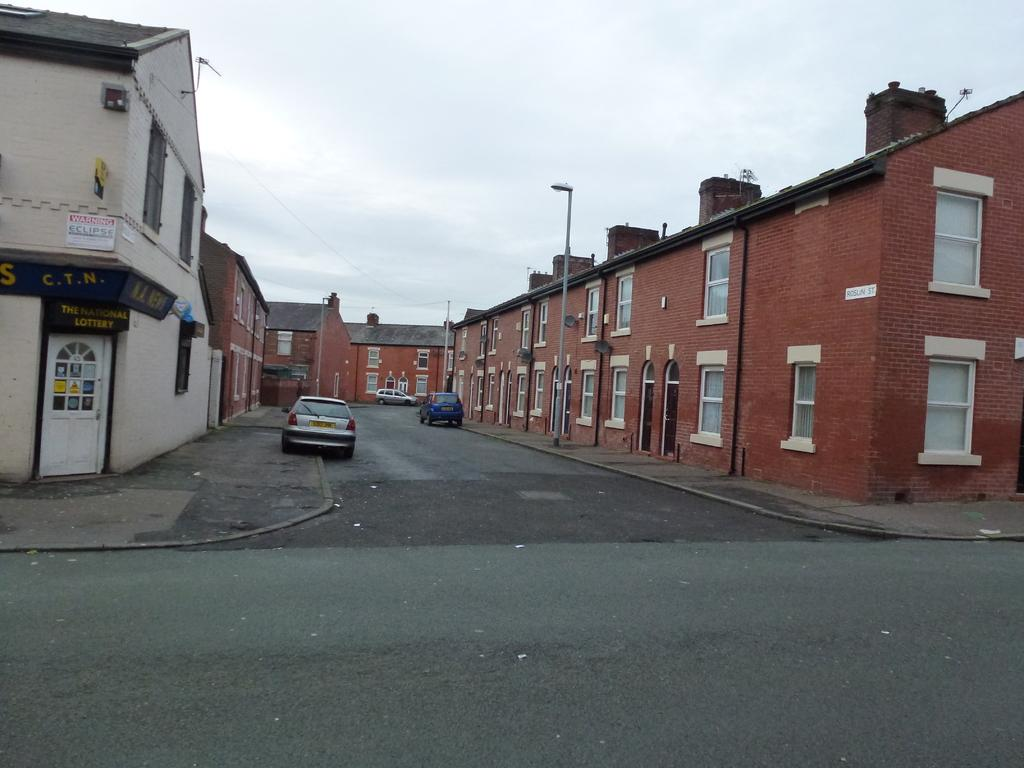What type of infrastructure is present in the image? There are roads in the image. What vehicles can be seen on the roads? There are cars in the image. What type of buildings are visible in the image? There are houses with windows on both sides of the image. What is visible at the top of the image? The sky is visible at the top of the image. Where is the shop located in the image? There is no shop present in the image. Is there a crook visible in the image? There is no crook present in the image. 